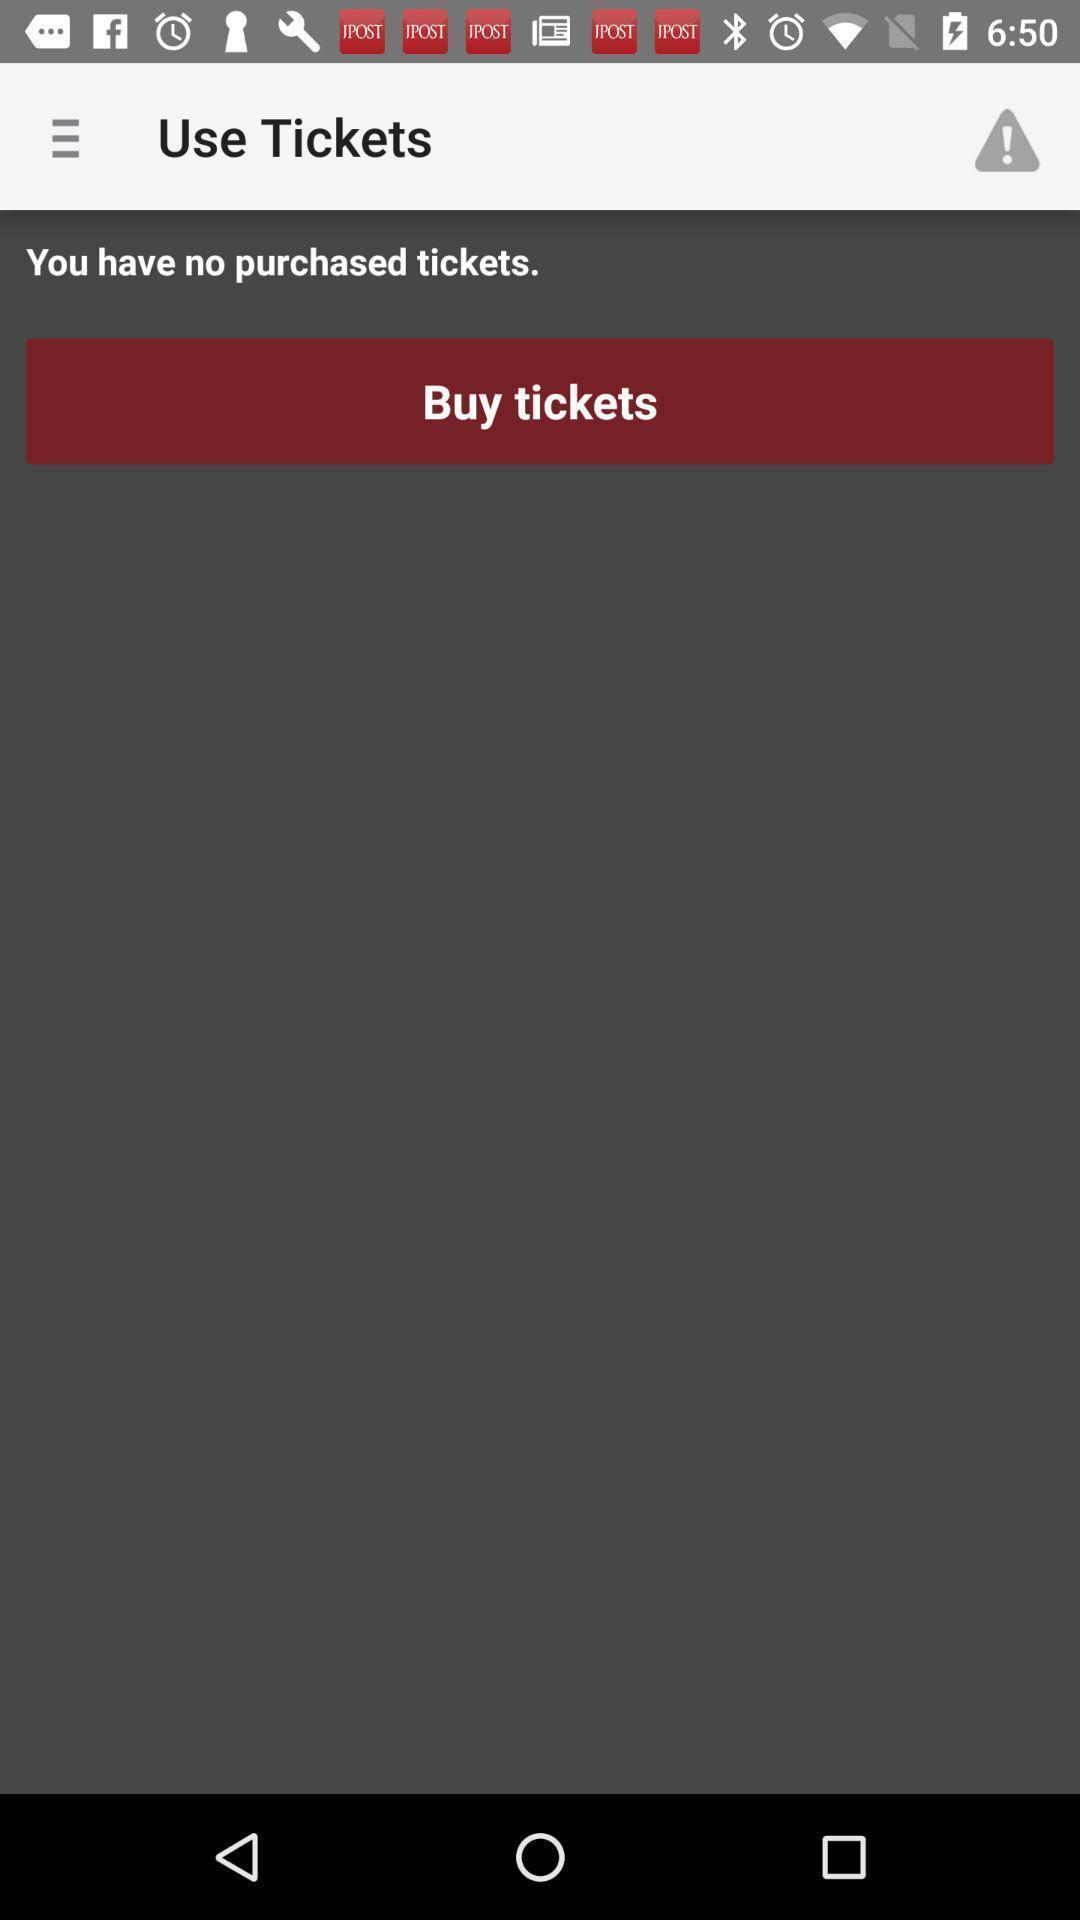Describe this image in words. Screen displaying results of tickets in a booking application. 